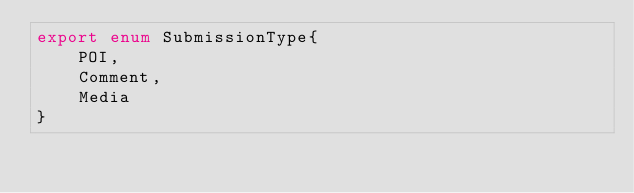Convert code to text. <code><loc_0><loc_0><loc_500><loc_500><_TypeScript_>export enum SubmissionType{
    POI,
    Comment,
    Media
}</code> 